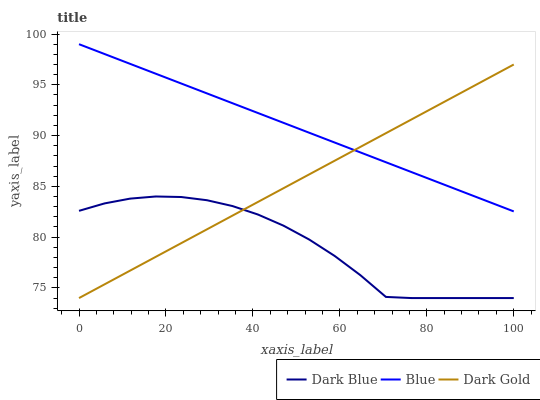Does Dark Blue have the minimum area under the curve?
Answer yes or no. Yes. Does Blue have the maximum area under the curve?
Answer yes or no. Yes. Does Dark Gold have the minimum area under the curve?
Answer yes or no. No. Does Dark Gold have the maximum area under the curve?
Answer yes or no. No. Is Blue the smoothest?
Answer yes or no. Yes. Is Dark Blue the roughest?
Answer yes or no. Yes. Is Dark Gold the smoothest?
Answer yes or no. No. Is Dark Gold the roughest?
Answer yes or no. No. Does Dark Blue have the lowest value?
Answer yes or no. Yes. Does Blue have the highest value?
Answer yes or no. Yes. Does Dark Gold have the highest value?
Answer yes or no. No. Is Dark Blue less than Blue?
Answer yes or no. Yes. Is Blue greater than Dark Blue?
Answer yes or no. Yes. Does Blue intersect Dark Gold?
Answer yes or no. Yes. Is Blue less than Dark Gold?
Answer yes or no. No. Is Blue greater than Dark Gold?
Answer yes or no. No. Does Dark Blue intersect Blue?
Answer yes or no. No. 